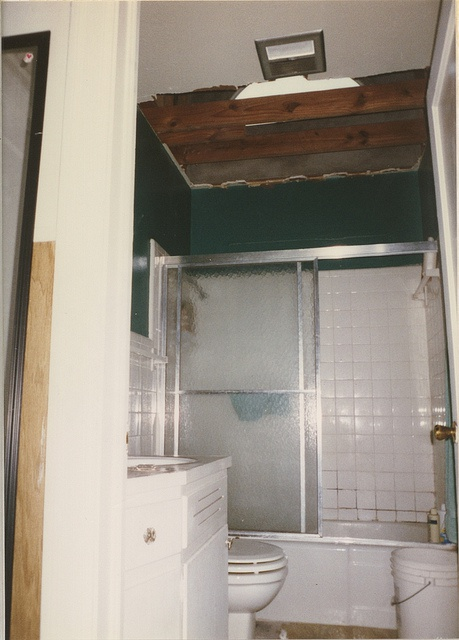Describe the objects in this image and their specific colors. I can see toilet in tan, darkgray, lightgray, and gray tones and sink in tan, lightgray, and darkgray tones in this image. 